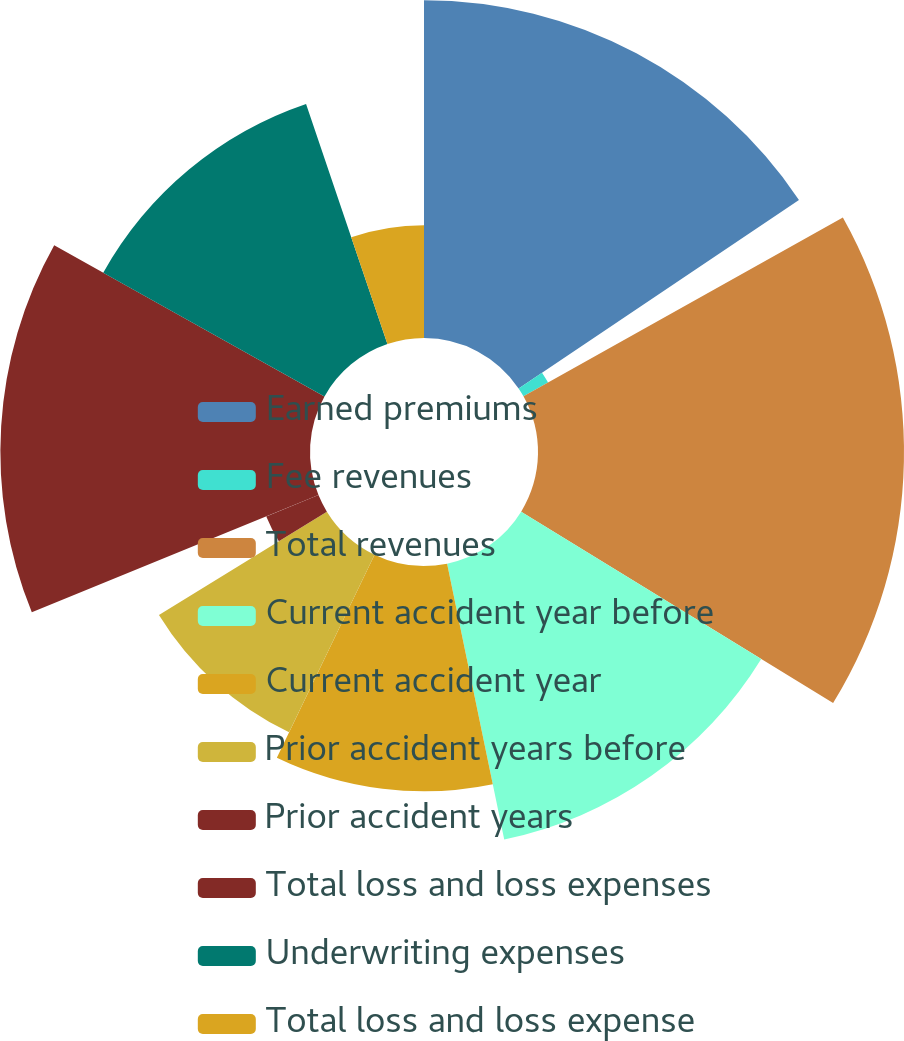Convert chart to OTSL. <chart><loc_0><loc_0><loc_500><loc_500><pie_chart><fcel>Earned premiums<fcel>Fee revenues<fcel>Total revenues<fcel>Current accident year before<fcel>Current accident year<fcel>Prior accident years before<fcel>Prior accident years<fcel>Total loss and loss expenses<fcel>Underwriting expenses<fcel>Total loss and loss expense<nl><fcel>15.58%<fcel>1.3%<fcel>16.88%<fcel>12.99%<fcel>10.39%<fcel>9.09%<fcel>2.6%<fcel>14.28%<fcel>11.69%<fcel>5.2%<nl></chart> 